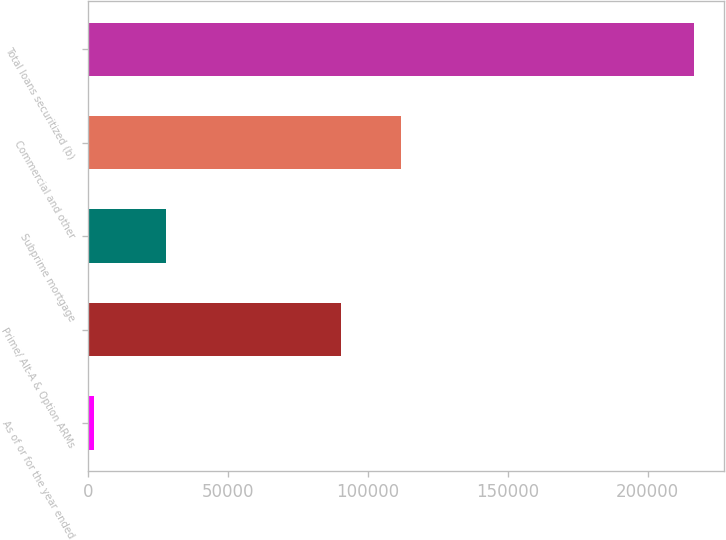<chart> <loc_0><loc_0><loc_500><loc_500><bar_chart><fcel>As of or for the year ended<fcel>Prime/ Alt-A & Option ARMs<fcel>Subprime mortgage<fcel>Commercial and other<fcel>Total loans securitized (b)<nl><fcel>2013<fcel>90381<fcel>28008<fcel>111820<fcel>216407<nl></chart> 